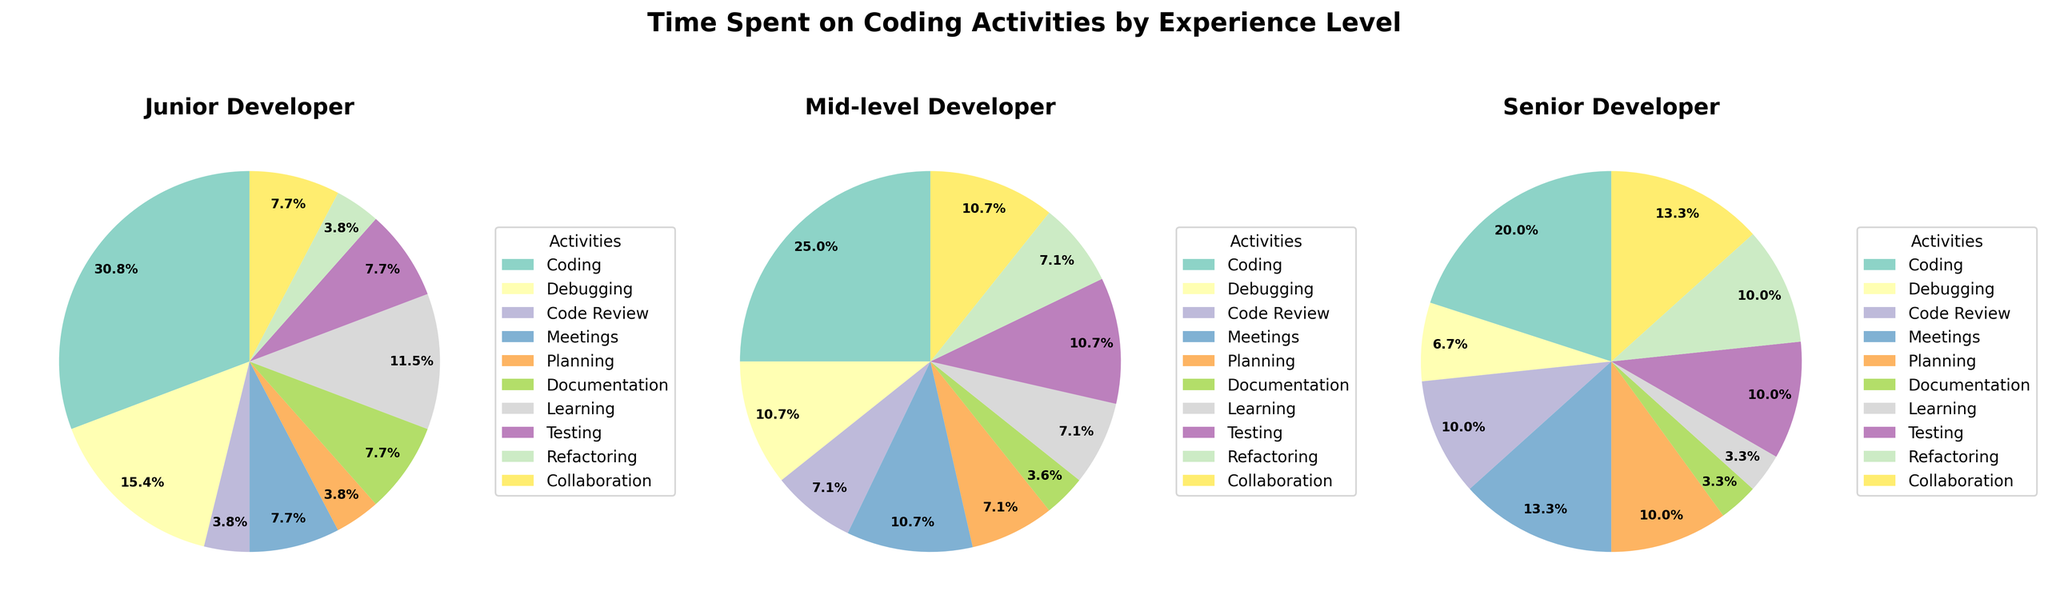what activity has the largest percentage of time spent by junior developers? To find this, we need to look at the pie chart for junior developers and identify which slice is the largest. The "Coding" activity slice is the biggest.
Answer: Coding How much more time do junior developers spend on coding compared to mid-level developers? Junior developers spend 4 hours on coding while mid-level developers spend 3.5 hours. Subtract the time spent by mid-level from junior: 4 - 3.5 = 0.5 hours.
Answer: 0.5 hours Which activity has the same percentage of time spent across all three experience levels? Looking at the three pie charts, the "Testing" activity has the same slice across all three charts. Each experience level shows 1.5 hours spent on testing.
Answer: Testing What percentage of time do senior developers spend in meetings relative to their total workday? The pie chart for senior developers shows a slice for meetings. It is labeled as taking up 2 hours. Since a workday is likely considered 8 hours, the percentage is (2 / 8) * 100 = 25%.
Answer: 25% Compare the time spent on documentation by junior and senior developers. Who spends less time and by how much? Junior developers spend 1 hour on documentation while senior developers spend 0.5 hours. Senior developers spend less time, so the difference is 1 - 0.5 = 0.5 hours.
Answer: Senior developers spend 0.5 hours less What is the total time spent on refactoring by all developers combined? Adding the time spent by junior (0.5), mid-level (1), and senior (1.5) developers: 0.5 + 1 + 1.5 = 3 hours.
Answer: 3 hours Which activity takes up the least amount of total time across all experience levels? Looking at all three pie charts, "Refactoring" and "Planning" seem to have small slices, but Refactoring has an overall smaller time. Summing up Refactoring: Junior (0.5), Mid-level (1), Senior (1.5) totals 3 hours, while Planning totals 3 hours as well. Both have the least, but Refactoring has slightly less comparatively as slices differ slightly.
Answer: Refactoring Find the average time spent on learning across all experience levels. Junior developers spend 1.5 hours, mid-level developers spend 1 hour, and senior developers spend 0.5 hours on learning. The average is (1.5 + 1 + 0.5) / 3 = 1 hour.
Answer: 1 hour Which activity shows an increasing trend in time spent from junior to senior developers? By examining each pie chart, "Code Review" shows an increasing trend: Junior (0.5 hours), Mid-level (1 hour), Senior (1.5 hours).
Answer: Code Review What is the ratio of time spent on collaboration by senior developers compared to junior developers? Senior developers spend 2 hours on collaboration while junior developers spend 1 hour. The ratio is 2:1.
Answer: 2:1 